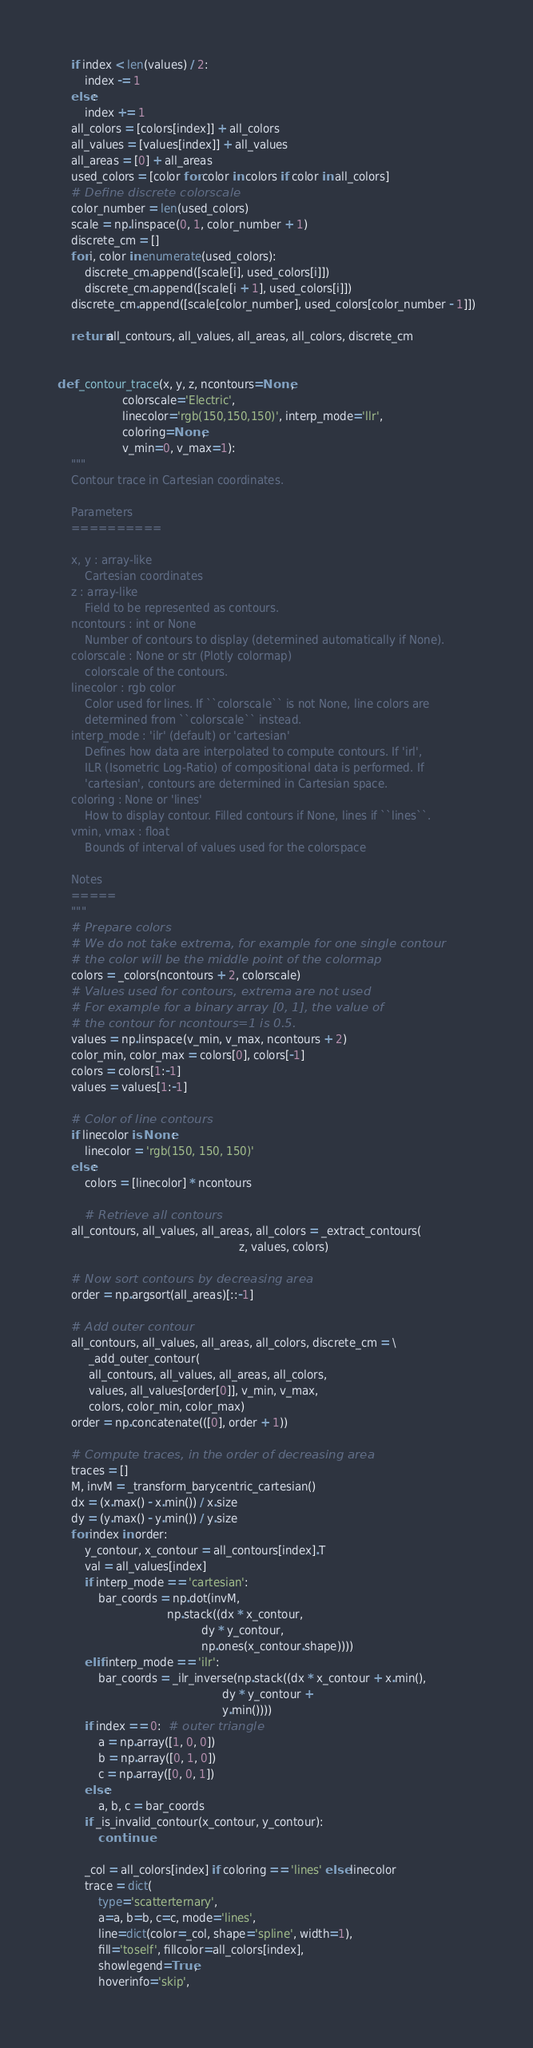Convert code to text. <code><loc_0><loc_0><loc_500><loc_500><_Python_>    if index < len(values) / 2:
        index -= 1
    else:
        index += 1
    all_colors = [colors[index]] + all_colors
    all_values = [values[index]] + all_values
    all_areas = [0] + all_areas
    used_colors = [color for color in colors if color in all_colors]
    # Define discrete colorscale
    color_number = len(used_colors)
    scale = np.linspace(0, 1, color_number + 1)
    discrete_cm = []
    for i, color in enumerate(used_colors):
        discrete_cm.append([scale[i], used_colors[i]])
        discrete_cm.append([scale[i + 1], used_colors[i]])
    discrete_cm.append([scale[color_number], used_colors[color_number - 1]])

    return all_contours, all_values, all_areas, all_colors, discrete_cm


def _contour_trace(x, y, z, ncontours=None,
                   colorscale='Electric',
                   linecolor='rgb(150,150,150)', interp_mode='llr',
                   coloring=None,
                   v_min=0, v_max=1):
    """
    Contour trace in Cartesian coordinates.

    Parameters
    ==========

    x, y : array-like
        Cartesian coordinates
    z : array-like
        Field to be represented as contours.
    ncontours : int or None
        Number of contours to display (determined automatically if None).
    colorscale : None or str (Plotly colormap)
        colorscale of the contours.
    linecolor : rgb color
        Color used for lines. If ``colorscale`` is not None, line colors are
        determined from ``colorscale`` instead.
    interp_mode : 'ilr' (default) or 'cartesian'
        Defines how data are interpolated to compute contours. If 'irl',
        ILR (Isometric Log-Ratio) of compositional data is performed. If
        'cartesian', contours are determined in Cartesian space.
    coloring : None or 'lines'
        How to display contour. Filled contours if None, lines if ``lines``.
    vmin, vmax : float
        Bounds of interval of values used for the colorspace

    Notes
    =====
    """
    # Prepare colors
    # We do not take extrema, for example for one single contour
    # the color will be the middle point of the colormap
    colors = _colors(ncontours + 2, colorscale)
    # Values used for contours, extrema are not used
    # For example for a binary array [0, 1], the value of
    # the contour for ncontours=1 is 0.5.
    values = np.linspace(v_min, v_max, ncontours + 2)
    color_min, color_max = colors[0], colors[-1]
    colors = colors[1:-1]
    values = values[1:-1]

    # Color of line contours
    if linecolor is None:
        linecolor = 'rgb(150, 150, 150)'
    else:
        colors = [linecolor] * ncontours

        # Retrieve all contours
    all_contours, all_values, all_areas, all_colors = _extract_contours(
                                                     z, values, colors)

    # Now sort contours by decreasing area
    order = np.argsort(all_areas)[::-1]

    # Add outer contour
    all_contours, all_values, all_areas, all_colors, discrete_cm = \
         _add_outer_contour(
         all_contours, all_values, all_areas, all_colors,
         values, all_values[order[0]], v_min, v_max,
         colors, color_min, color_max)
    order = np.concatenate(([0], order + 1))

    # Compute traces, in the order of decreasing area
    traces = []
    M, invM = _transform_barycentric_cartesian()
    dx = (x.max() - x.min()) / x.size
    dy = (y.max() - y.min()) / y.size
    for index in order:
        y_contour, x_contour = all_contours[index].T
        val = all_values[index]
        if interp_mode == 'cartesian':
            bar_coords = np.dot(invM,
                                np.stack((dx * x_contour,
                                          dy * y_contour,
                                          np.ones(x_contour.shape))))
        elif interp_mode == 'ilr':
            bar_coords = _ilr_inverse(np.stack((dx * x_contour + x.min(),
                                                dy * y_contour +
                                                y.min())))
        if index == 0:  # outer triangle
            a = np.array([1, 0, 0])
            b = np.array([0, 1, 0])
            c = np.array([0, 0, 1])
        else:
            a, b, c = bar_coords
        if _is_invalid_contour(x_contour, y_contour):
            continue

        _col = all_colors[index] if coloring == 'lines' else linecolor
        trace = dict(
            type='scatterternary',
            a=a, b=b, c=c, mode='lines',
            line=dict(color=_col, shape='spline', width=1),
            fill='toself', fillcolor=all_colors[index],
            showlegend=True,
            hoverinfo='skip',</code> 